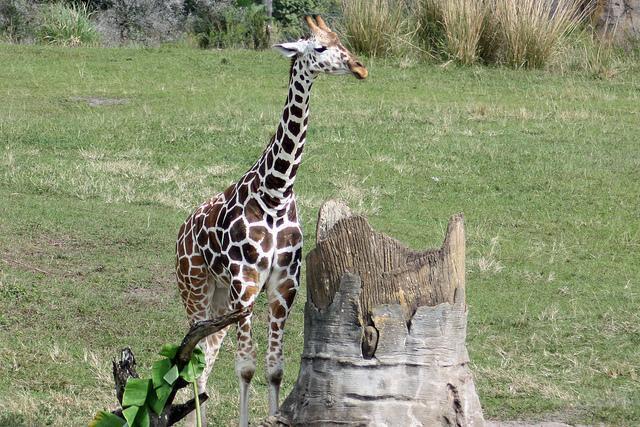How many giraffes are in the scene?
Give a very brief answer. 1. How many boats are to the right of the stop sign?
Give a very brief answer. 0. 